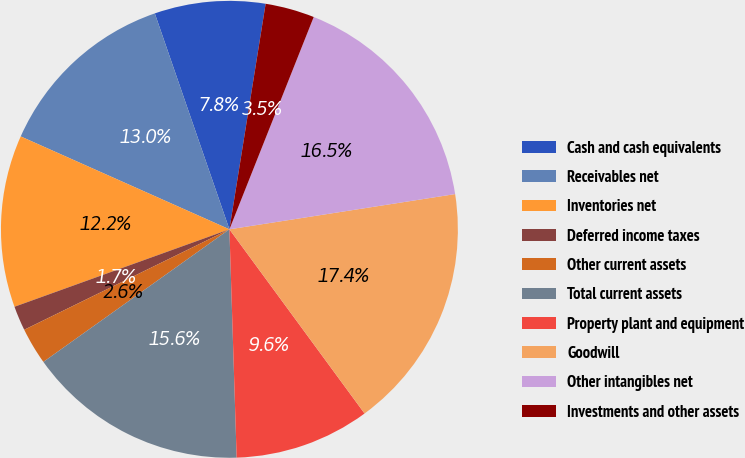Convert chart to OTSL. <chart><loc_0><loc_0><loc_500><loc_500><pie_chart><fcel>Cash and cash equivalents<fcel>Receivables net<fcel>Inventories net<fcel>Deferred income taxes<fcel>Other current assets<fcel>Total current assets<fcel>Property plant and equipment<fcel>Goodwill<fcel>Other intangibles net<fcel>Investments and other assets<nl><fcel>7.83%<fcel>13.04%<fcel>12.17%<fcel>1.74%<fcel>2.61%<fcel>15.65%<fcel>9.57%<fcel>17.39%<fcel>16.52%<fcel>3.48%<nl></chart> 